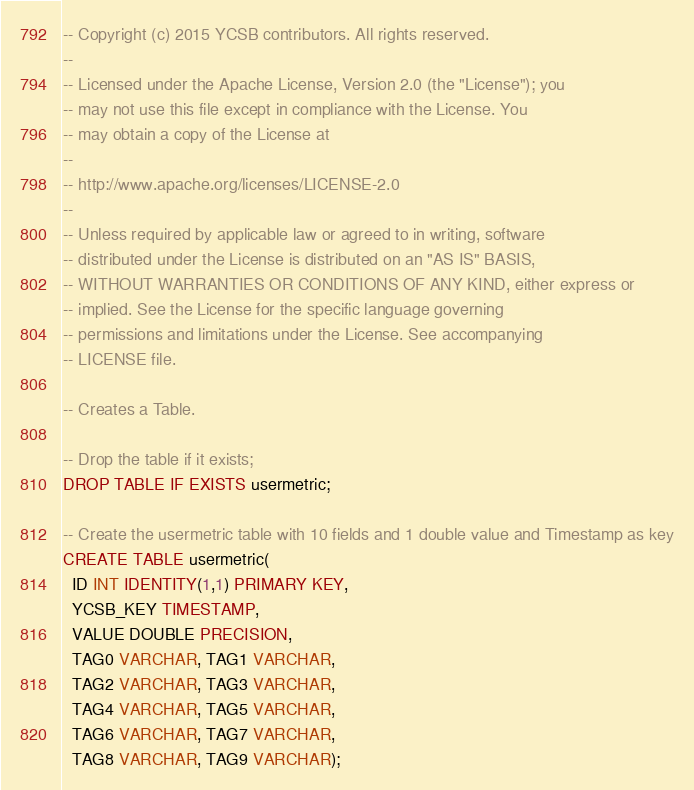Convert code to text. <code><loc_0><loc_0><loc_500><loc_500><_SQL_>-- Copyright (c) 2015 YCSB contributors. All rights reserved.
--
-- Licensed under the Apache License, Version 2.0 (the "License"); you
-- may not use this file except in compliance with the License. You
-- may obtain a copy of the License at
--
-- http://www.apache.org/licenses/LICENSE-2.0
--
-- Unless required by applicable law or agreed to in writing, software
-- distributed under the License is distributed on an "AS IS" BASIS,
-- WITHOUT WARRANTIES OR CONDITIONS OF ANY KIND, either express or
-- implied. See the License for the specific language governing
-- permissions and limitations under the License. See accompanying
-- LICENSE file.

-- Creates a Table.

-- Drop the table if it exists;
DROP TABLE IF EXISTS usermetric;

-- Create the usermetric table with 10 fields and 1 double value and Timestamp as key
CREATE TABLE usermetric(
  ID INT IDENTITY(1,1) PRIMARY KEY,
  YCSB_KEY TIMESTAMP,
  VALUE DOUBLE PRECISION,
  TAG0 VARCHAR, TAG1 VARCHAR,
  TAG2 VARCHAR, TAG3 VARCHAR,
  TAG4 VARCHAR, TAG5 VARCHAR,
  TAG6 VARCHAR, TAG7 VARCHAR,
  TAG8 VARCHAR, TAG9 VARCHAR);
</code> 